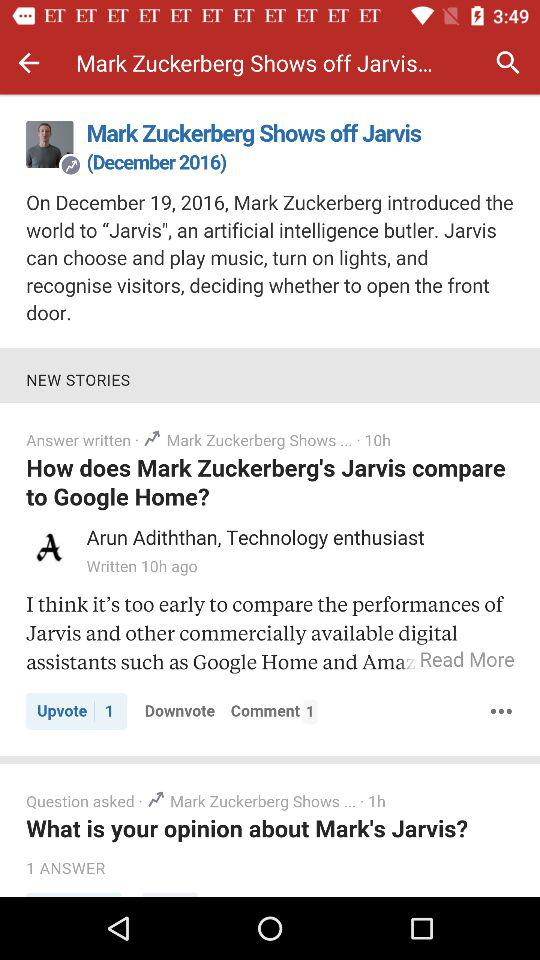How many hours ago was the answer to the question written?
Answer the question using a single word or phrase. 10h 